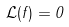Convert formula to latex. <formula><loc_0><loc_0><loc_500><loc_500>\mathcal { L } ( f ) = 0</formula> 